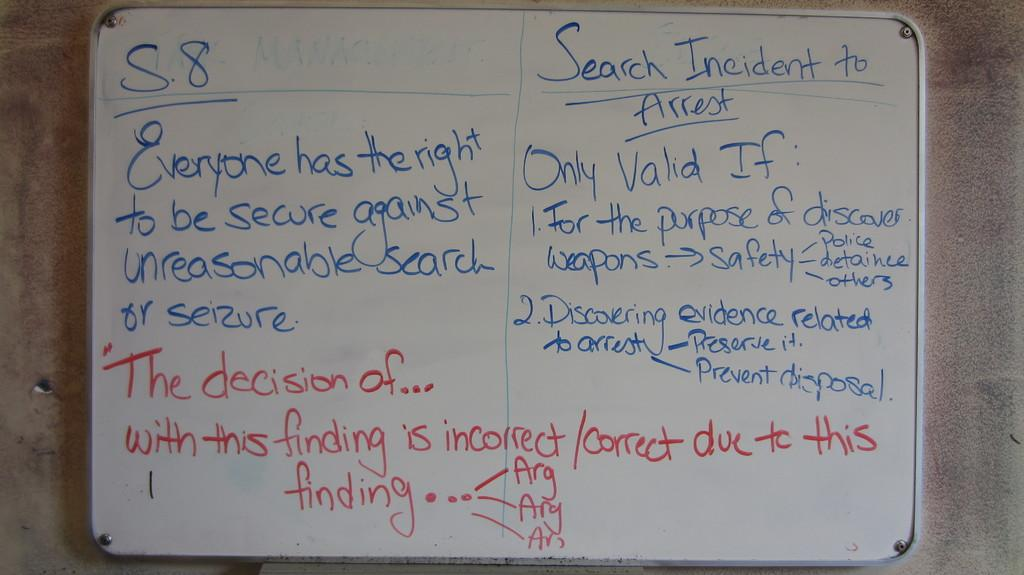<image>
Share a concise interpretation of the image provided. A whiteboard says "Search Incident to Arrest" at the top. 